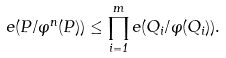<formula> <loc_0><loc_0><loc_500><loc_500>e ( P / \varphi ^ { n } ( P ) ) \leq \prod _ { i = 1 } ^ { m } e ( Q _ { i } / \varphi ( Q _ { i } ) ) .</formula> 